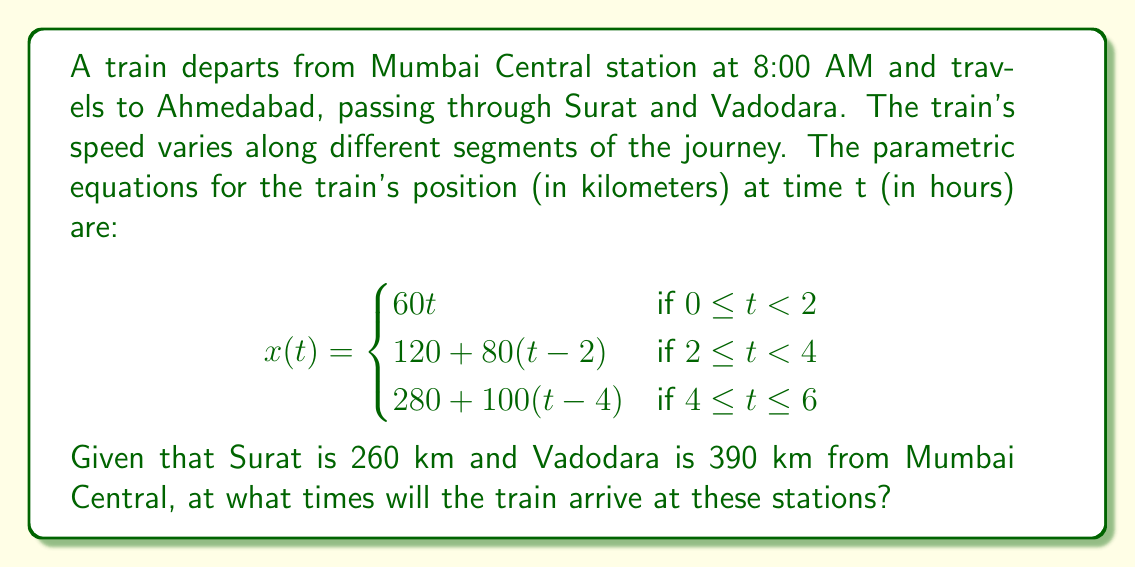Teach me how to tackle this problem. To solve this problem, we need to find the values of t when x(t) equals 260 km (for Surat) and 390 km (for Vadodara). Let's approach this step-by-step:

1. For Surat (260 km):
   We can see that 260 km falls in the second segment of the piecewise function.
   $$260 = 120 + 80(t-2)$$
   $$140 = 80(t-2)$$
   $$1.75 = t-2$$
   $$t = 3.75$$

   So, the train arrives at Surat 3.75 hours after departure.
   Time of arrival at Surat = 8:00 AM + 3 hours 45 minutes = 11:45 AM

2. For Vadodara (390 km):
   This distance falls in the third segment of the function.
   $$390 = 280 + 100(t-4)$$
   $$110 = 100(t-4)$$
   $$1.1 = t-4$$
   $$t = 5.1$$

   The train arrives at Vadodara 5.1 hours after departure.
   Time of arrival at Vadodara = 8:00 AM + 5 hours 6 minutes = 1:06 PM

To convert the decimal hours to hours and minutes:
- For Surat: 0.75 hours = 0.75 * 60 = 45 minutes
- For Vadodara: 0.1 hours = 0.1 * 60 = 6 minutes
Answer: The train will arrive at Surat at 11:45 AM and at Vadodara at 1:06 PM. 